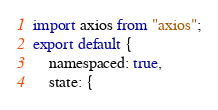Convert code to text. <code><loc_0><loc_0><loc_500><loc_500><_JavaScript_>import axios from "axios";
export default {
    namespaced: true,
    state: {</code> 